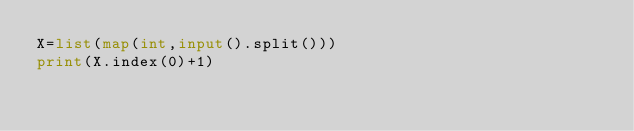<code> <loc_0><loc_0><loc_500><loc_500><_Python_>X=list(map(int,input().split()))
print(X.index(0)+1)</code> 